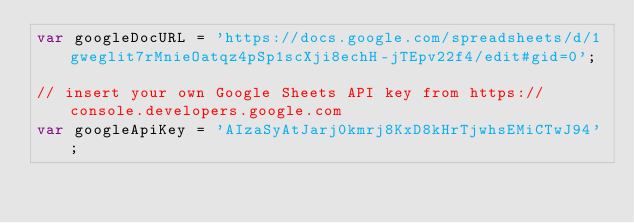<code> <loc_0><loc_0><loc_500><loc_500><_JavaScript_>var googleDocURL = 'https://docs.google.com/spreadsheets/d/1gweglit7rMnieOatqz4pSp1scXji8echH-jTEpv22f4/edit#gid=0';

// insert your own Google Sheets API key from https://console.developers.google.com
var googleApiKey = 'AIzaSyAtJarj0kmrj8KxD8kHrTjwhsEMiCTwJ94';
</code> 